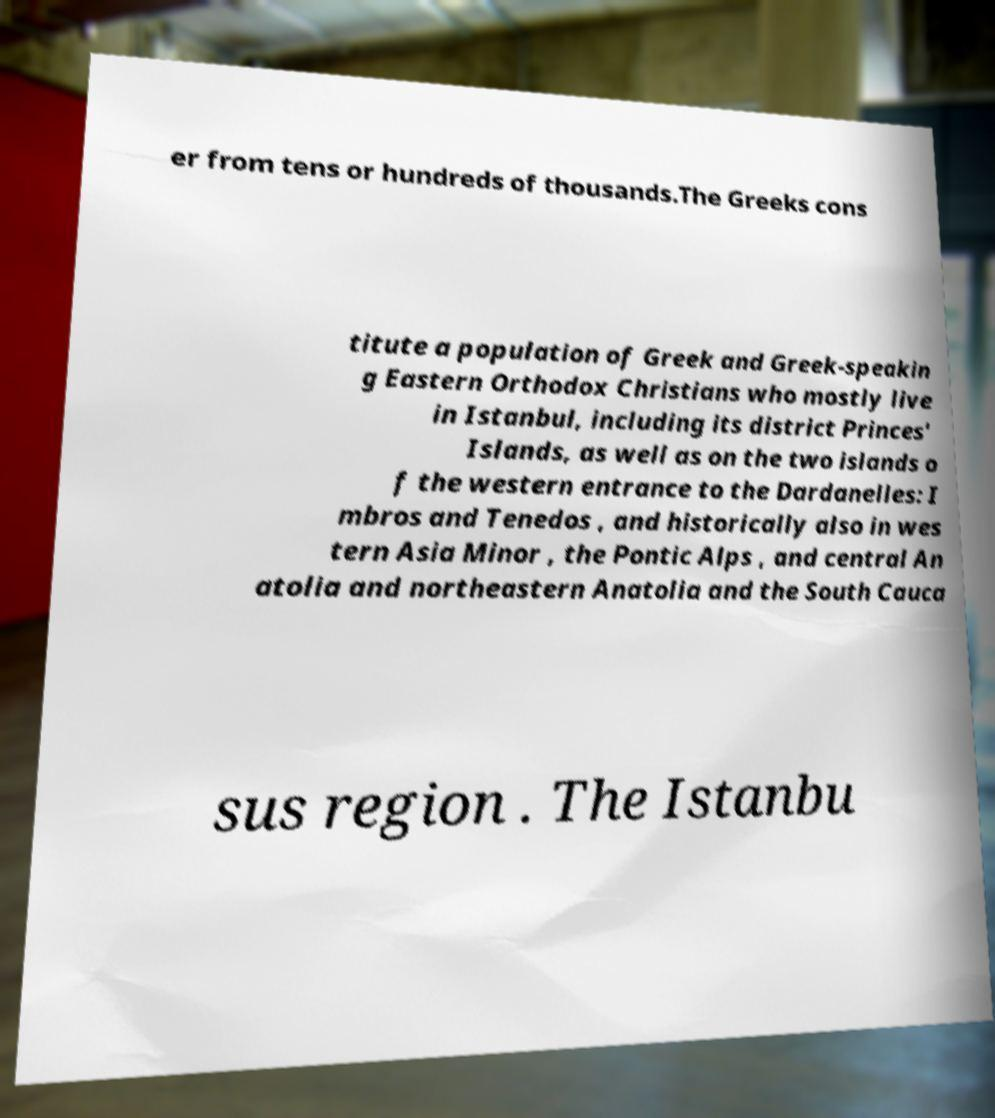Please identify and transcribe the text found in this image. er from tens or hundreds of thousands.The Greeks cons titute a population of Greek and Greek-speakin g Eastern Orthodox Christians who mostly live in Istanbul, including its district Princes' Islands, as well as on the two islands o f the western entrance to the Dardanelles: I mbros and Tenedos , and historically also in wes tern Asia Minor , the Pontic Alps , and central An atolia and northeastern Anatolia and the South Cauca sus region . The Istanbu 